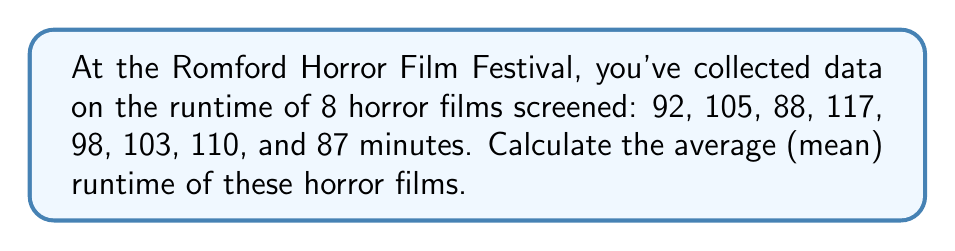Solve this math problem. To calculate the average (mean) runtime of the horror films, we need to follow these steps:

1. Sum up all the runtimes:
   $92 + 105 + 88 + 117 + 98 + 103 + 110 + 87 = 800$ minutes

2. Count the total number of films:
   There are 8 films in total.

3. Apply the formula for the arithmetic mean:
   $\text{Mean} = \frac{\text{Sum of all values}}{\text{Number of values}}$

   $$\text{Mean} = \frac{800}{8} = 100$$

Therefore, the average runtime of the horror films screened at the festival is 100 minutes.
Answer: 100 minutes 